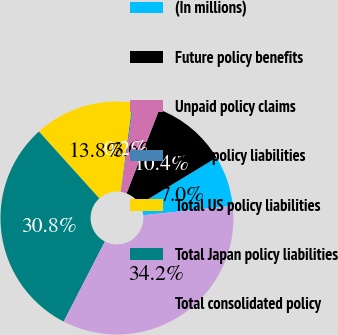<chart> <loc_0><loc_0><loc_500><loc_500><pie_chart><fcel>(In millions)<fcel>Future policy benefits<fcel>Unpaid policy claims<fcel>Other policy liabilities<fcel>Total US policy liabilities<fcel>Total Japan policy liabilities<fcel>Total consolidated policy<nl><fcel>7.0%<fcel>10.41%<fcel>3.6%<fcel>0.19%<fcel>13.81%<fcel>30.75%<fcel>34.24%<nl></chart> 